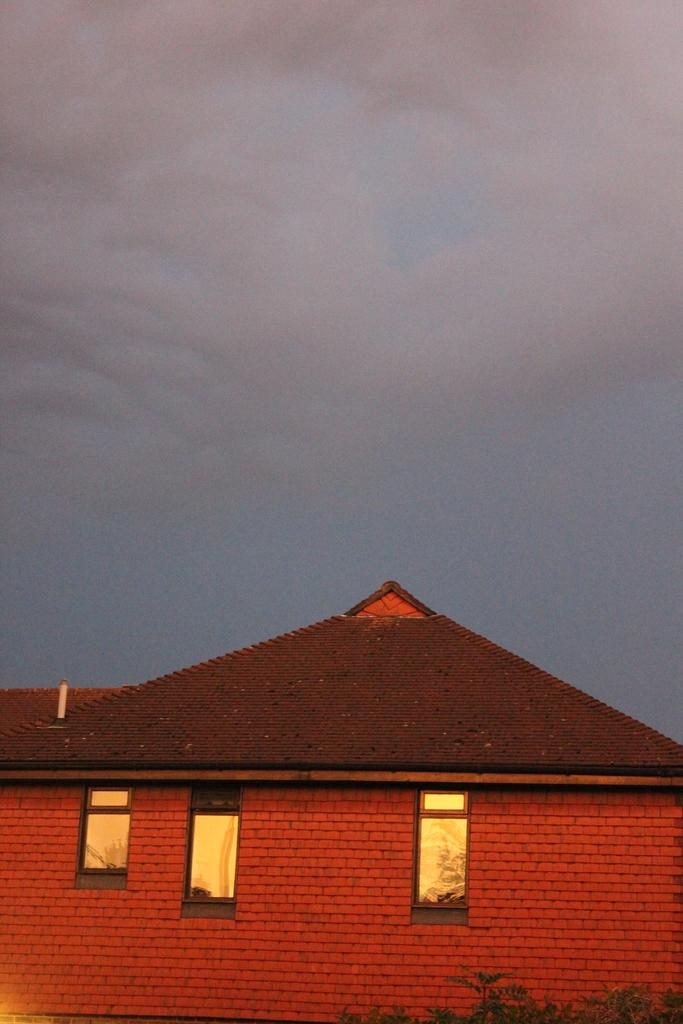What structure is located at the bottom of the image? There is a shed at the bottom of the image. What can be seen in the background of the image? The sky is visible in the background of the image. What type of vegetation is at the bottom of the image? There are plants at the bottom of the image. How many friends are playing in the mine in the image? There is no mine or friends present in the image. What type of tree is growing near the shed in the image? There is no tree present in the image. 